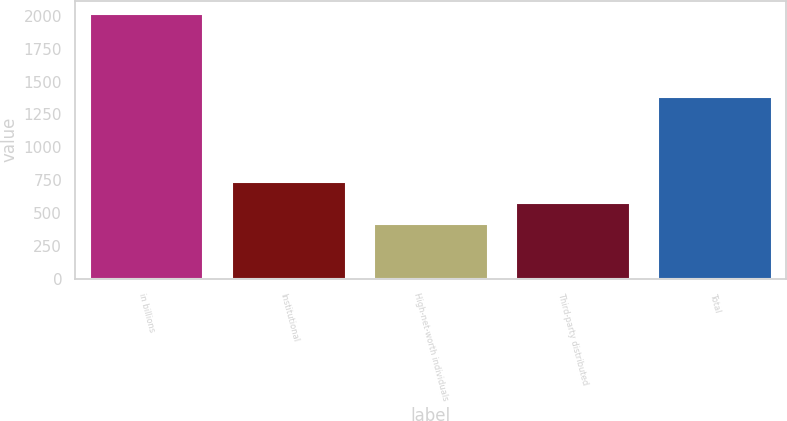<chart> <loc_0><loc_0><loc_500><loc_500><bar_chart><fcel>in billions<fcel>Institutional<fcel>High-net-worth individuals<fcel>Third-party distributed<fcel>Total<nl><fcel>2016<fcel>733.6<fcel>413<fcel>573.3<fcel>1379<nl></chart> 